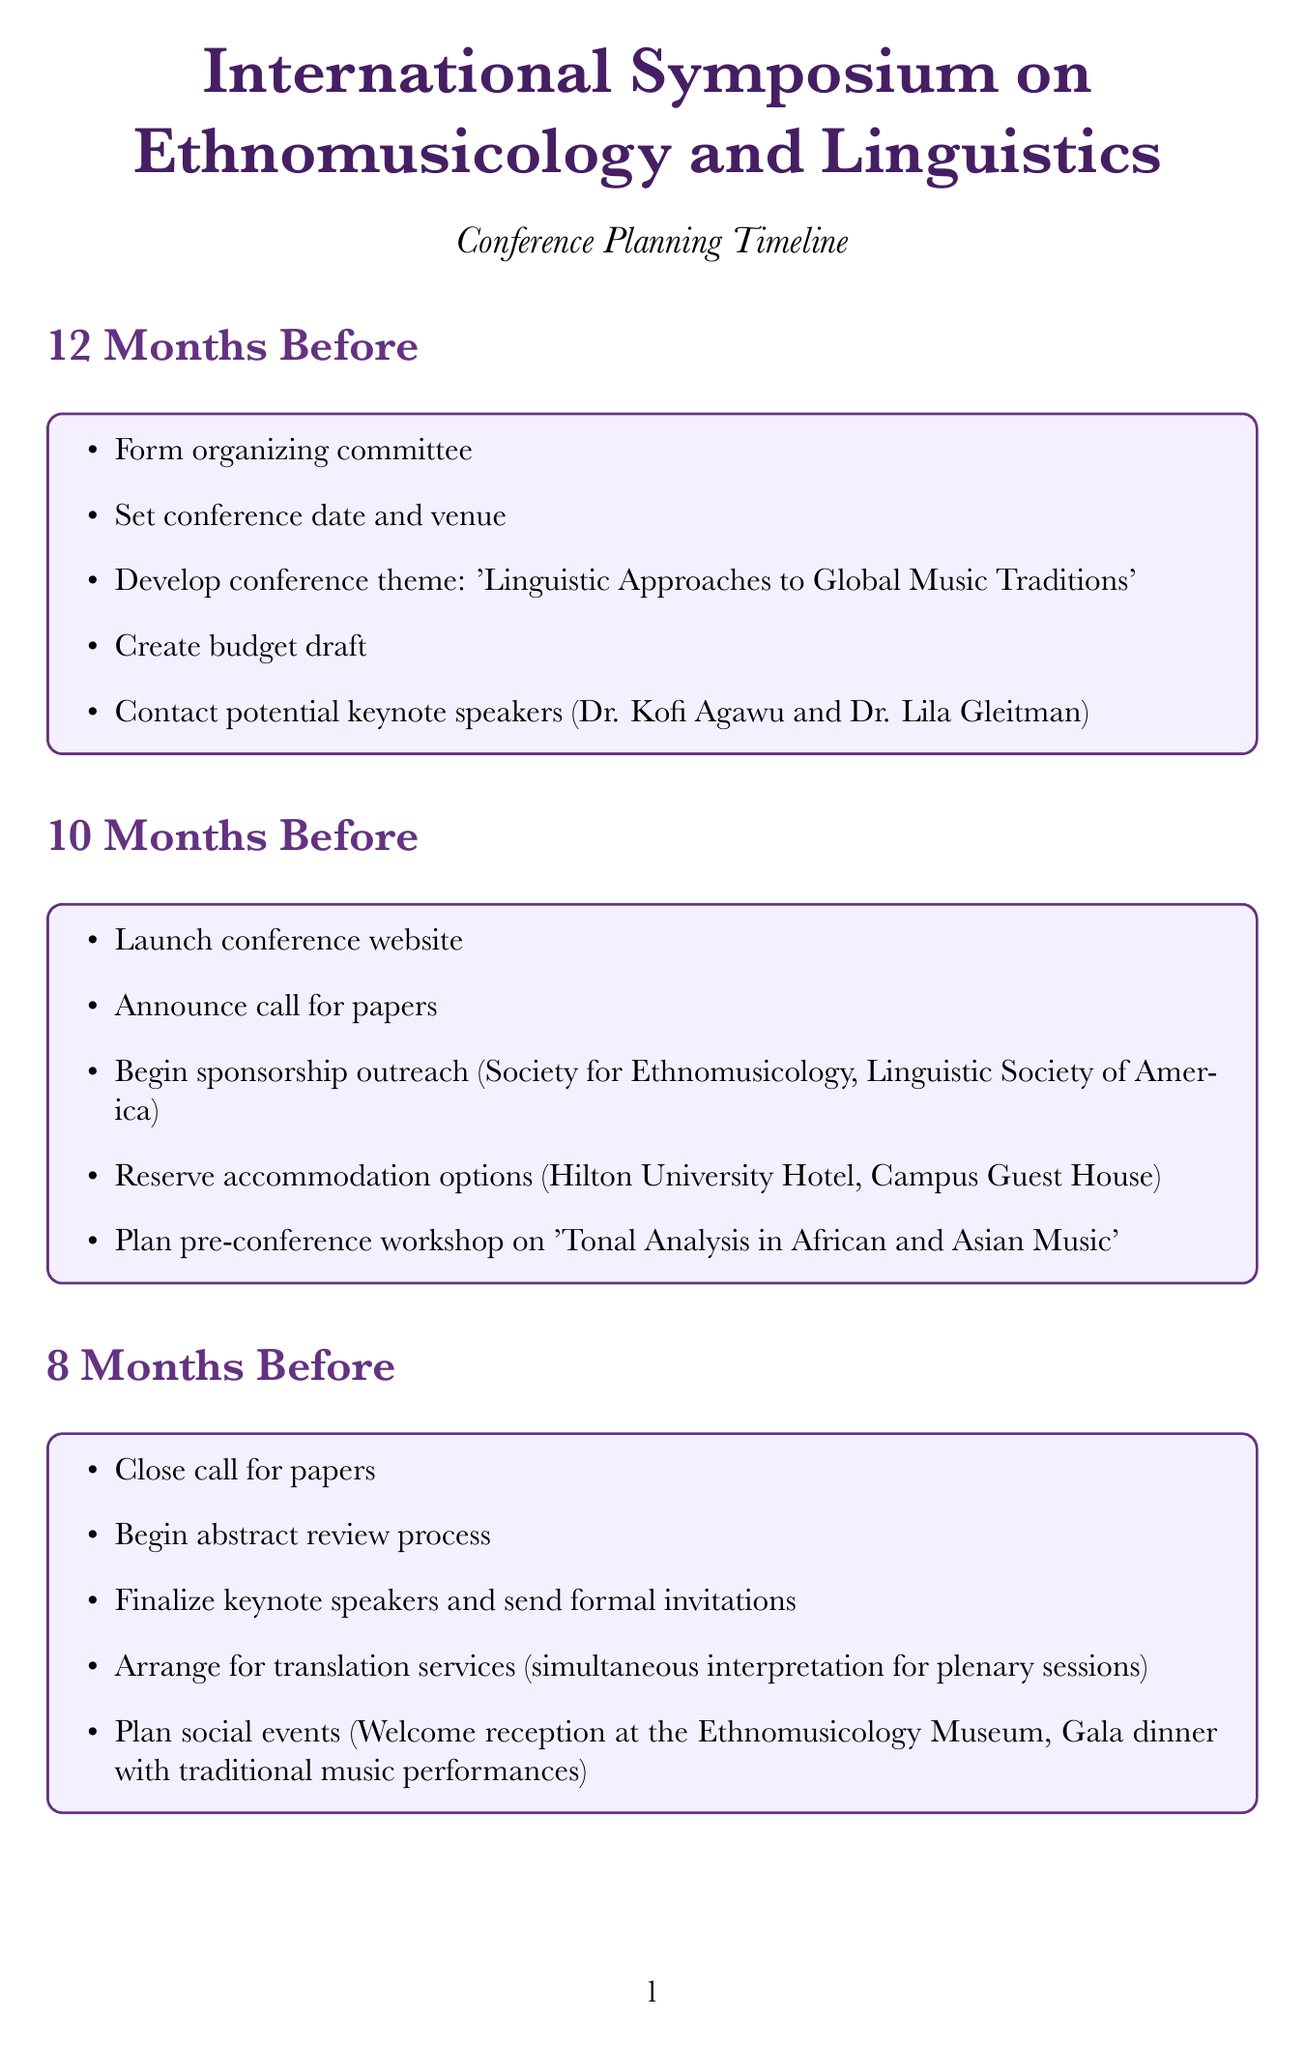what is the conference theme? The conference theme is stated explicitly in the document as 'Linguistic Approaches to Global Music Traditions'.
Answer: 'Linguistic Approaches to Global Music Traditions' how many months before the event does the early bird registration open? The document states that early bird registration opens 6 months before the event.
Answer: 6 who are the two potential keynote speakers? The document provides names of two keynote speakers: Dr. Kofi Agawu and Dr. Lila Gleitman.
Answer: Dr. Kofi Agawu and Dr. Lila Gleitman what is the last task mentioned before the event? The last task listed in the document before the event occurs is setting up social media channels for real-time updates.
Answer: Set up social media channels for real-time conference updates how many months before the conference does the call for papers close? According to the timeline in the document, the call for papers closes 8 months before the conference.
Answer: 8 what type of workshop is planned for the pre-conference? The document specifies a workshop on 'Tonal Analysis in African and Asian Music'.
Answer: 'Tonal Analysis in African and Asian Music' what follows the conference tasks in the timeline? The document includes a section titled "Post-Conference Tasks" that follows the conference tasks.
Answer: Post-Conference Tasks how many tasks are listed for the 4 months before the event? The document outlines five tasks for the 4 months before the event.
Answer: 5 when should final reminders be sent to participants? The document indicates that final reminders should be sent 1 month before the event.
Answer: 1 month 